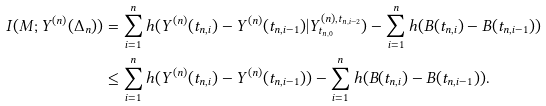<formula> <loc_0><loc_0><loc_500><loc_500>I ( M ; Y ^ { ( n ) } ( \Delta _ { n } ) ) & = \sum _ { i = 1 } ^ { n } h ( Y ^ { ( n ) } ( t _ { n , i } ) - Y ^ { ( n ) } ( t _ { n , i - 1 } ) | Y ^ { ( n ) , t _ { n , i - 2 } } _ { t _ { n , 0 } } ) - \sum _ { i = 1 } ^ { n } h ( B ( t _ { n , i } ) - B ( t _ { n , i - 1 } ) ) \\ & \leq \sum _ { i = 1 } ^ { n } h ( Y ^ { ( n ) } ( t _ { n , i } ) - Y ^ { ( n ) } ( t _ { n , i - 1 } ) ) - \sum _ { i = 1 } ^ { n } h ( B ( t _ { n , i } ) - B ( t _ { n , i - 1 } ) ) .</formula> 